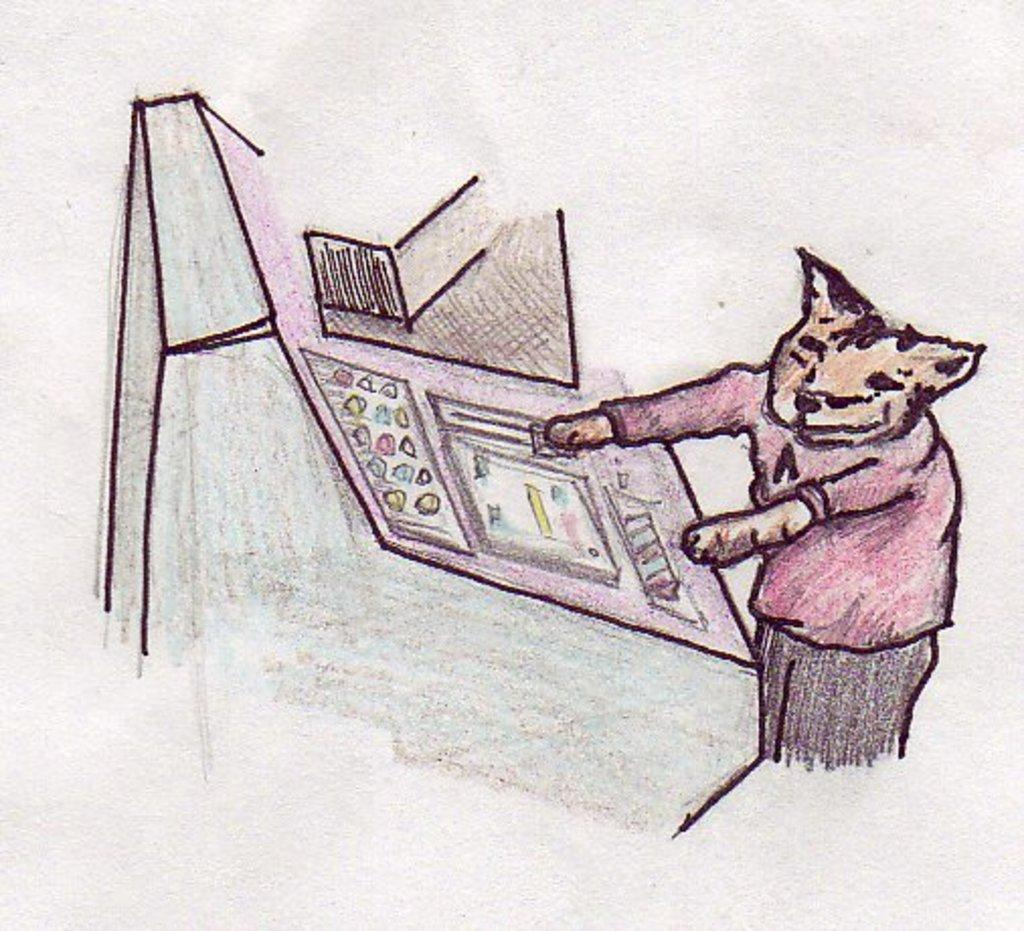What type of artwork is shown in the image? The image is a drawing. What is the main subject of the drawing? There is an animal depicted in the drawing. Where is the animal located in the drawing? The animal is on the right side of the drawing. What type of slave is depicted in the drawing? There is no slave depicted in the drawing; it features an animal. Is there a fight happening between the animal and another creature in the drawing? There is no fight depicted in the drawing; it only shows an animal on the right side. 